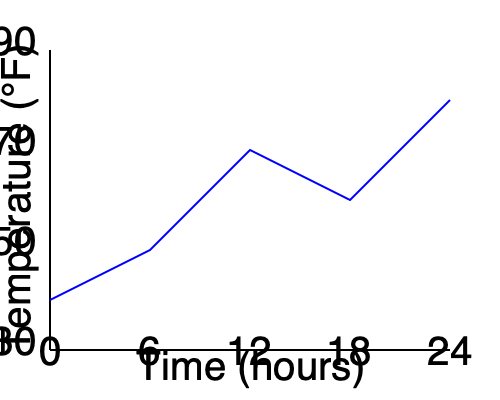The graph shows the temperature changes in Madison, Wisconsin over a 24-hour period. What was the approximate temperature difference between the highest and lowest points during this time? To find the temperature difference between the highest and lowest points, we need to:

1. Identify the highest point on the graph:
   - This occurs at the 24-hour mark (far right of the graph)
   - The temperature appears to be around 85°F

2. Identify the lowest point on the graph:
   - This occurs at the 0-hour mark (far left of the graph)
   - The temperature appears to be around 40°F

3. Calculate the difference:
   $85°F - 40°F = 45°F$

Therefore, the approximate temperature difference between the highest and lowest points is 45°F.
Answer: 45°F 